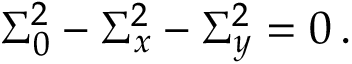<formula> <loc_0><loc_0><loc_500><loc_500>\Sigma _ { 0 } ^ { 2 } - \Sigma _ { x } ^ { 2 } - \Sigma _ { y } ^ { 2 } = 0 \, .</formula> 